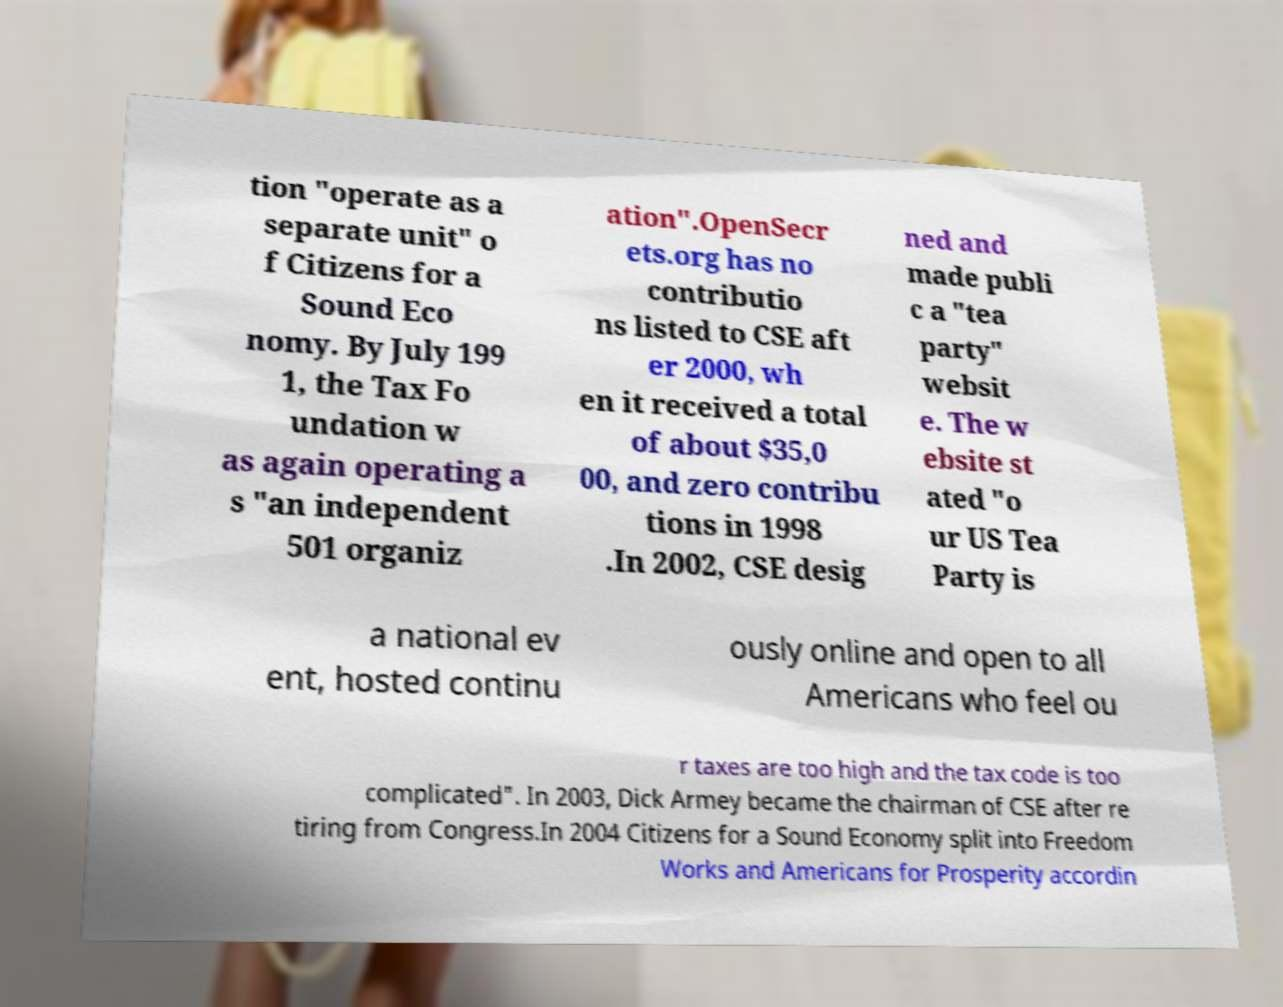Please identify and transcribe the text found in this image. tion "operate as a separate unit" o f Citizens for a Sound Eco nomy. By July 199 1, the Tax Fo undation w as again operating a s "an independent 501 organiz ation".OpenSecr ets.org has no contributio ns listed to CSE aft er 2000, wh en it received a total of about $35,0 00, and zero contribu tions in 1998 .In 2002, CSE desig ned and made publi c a "tea party" websit e. The w ebsite st ated "o ur US Tea Party is a national ev ent, hosted continu ously online and open to all Americans who feel ou r taxes are too high and the tax code is too complicated". In 2003, Dick Armey became the chairman of CSE after re tiring from Congress.In 2004 Citizens for a Sound Economy split into Freedom Works and Americans for Prosperity accordin 